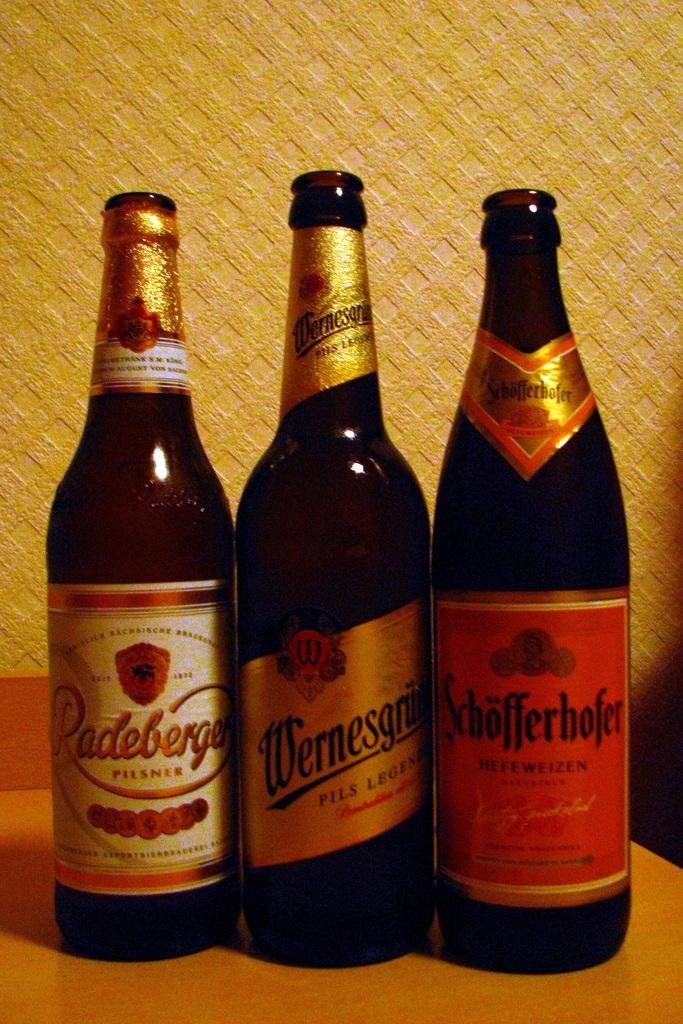<image>
Offer a succinct explanation of the picture presented. three bottles of German styled brewed Pilsner style beers 